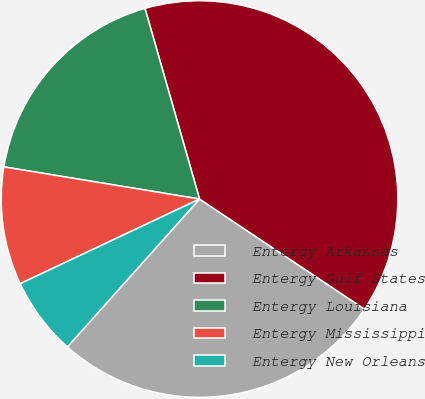Convert chart. <chart><loc_0><loc_0><loc_500><loc_500><pie_chart><fcel>Entergy Arkansas<fcel>Entergy Gulf States<fcel>Entergy Louisiana<fcel>Entergy Mississippi<fcel>Entergy New Orleans<nl><fcel>27.24%<fcel>38.8%<fcel>17.97%<fcel>9.61%<fcel>6.37%<nl></chart> 